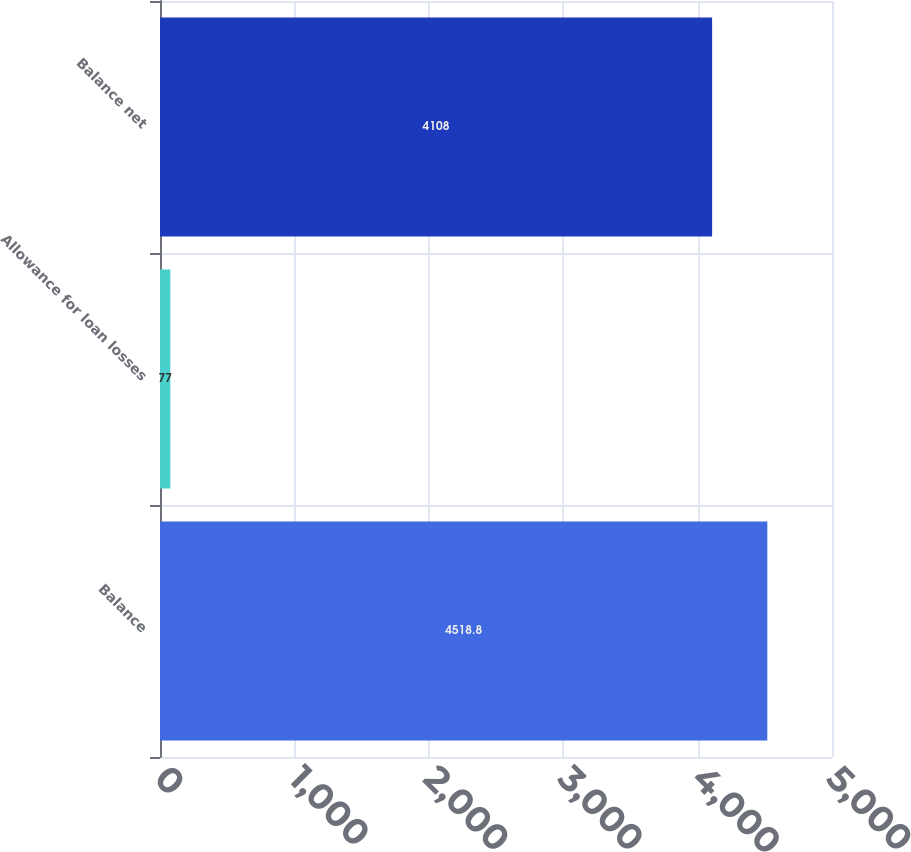Convert chart. <chart><loc_0><loc_0><loc_500><loc_500><bar_chart><fcel>Balance<fcel>Allowance for loan losses<fcel>Balance net<nl><fcel>4518.8<fcel>77<fcel>4108<nl></chart> 